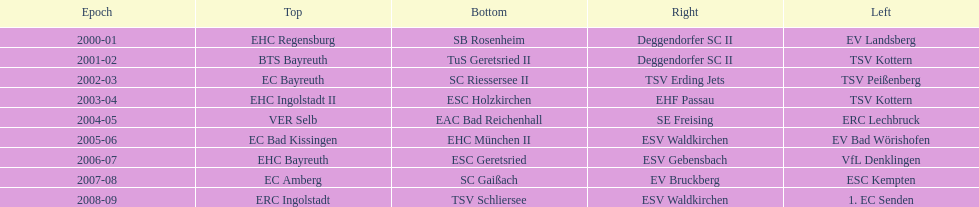What was the first club for the north in the 2000's? EHC Regensburg. 